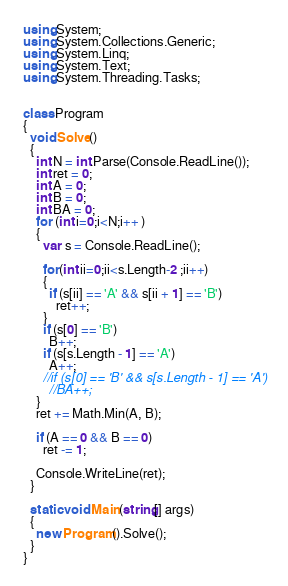Convert code to text. <code><loc_0><loc_0><loc_500><loc_500><_C#_>using System;
using System.Collections.Generic;
using System.Linq;
using System.Text;
using System.Threading.Tasks;


class Program
{
  void Solve()
  {
    int N = int.Parse(Console.ReadLine());
    int ret = 0;
    int A = 0;
    int B = 0;
    int BA = 0;
    for (int i=0;i<N;i++ )
    {
      var s = Console.ReadLine();

      for(int ii=0;ii<s.Length-2 ;ii++)
      {
        if (s[ii] == 'A' && s[ii + 1] == 'B')
          ret++;
      }
      if (s[0] == 'B')
        B++;
      if (s[s.Length - 1] == 'A')
        A++;
      //if (s[0] == 'B' && s[s.Length - 1] == 'A')
        //BA++;
    }
    ret += Math.Min(A, B);

    if (A == 0 && B == 0)
      ret -= 1;

    Console.WriteLine(ret);
  }

  static void Main(string[] args)
  {
    new Program().Solve();
  }
}

</code> 